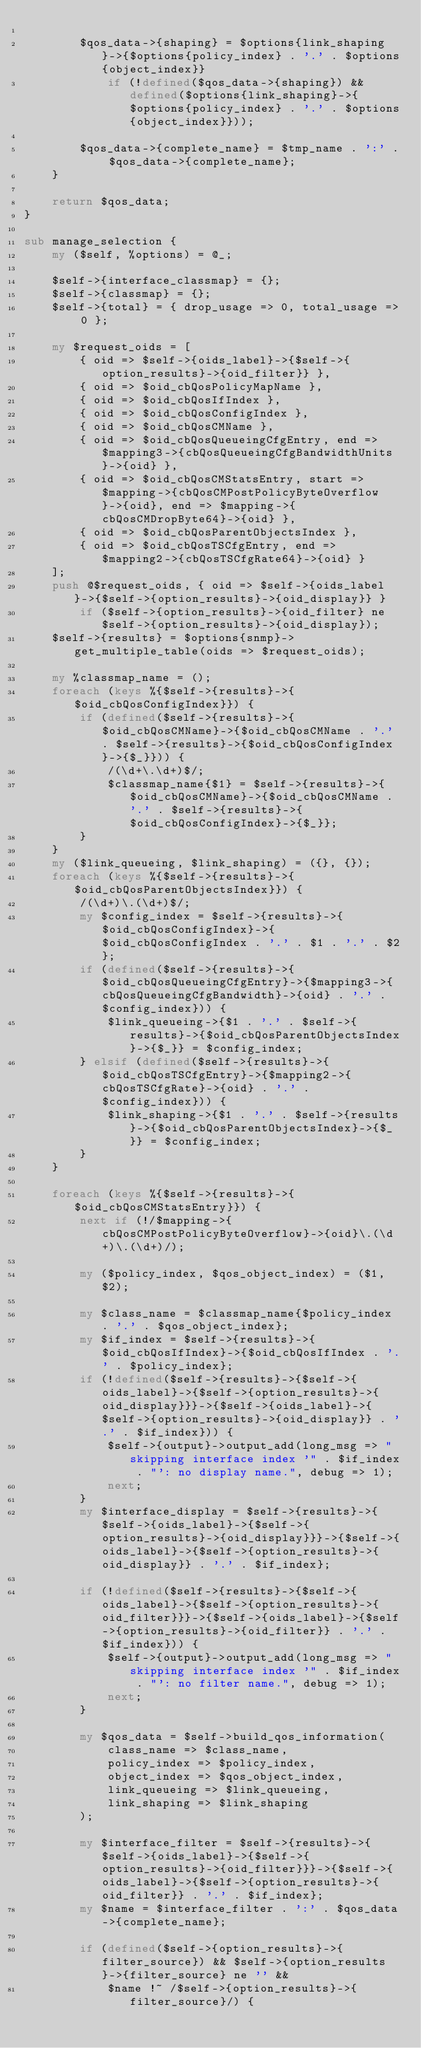<code> <loc_0><loc_0><loc_500><loc_500><_Perl_>
        $qos_data->{shaping} = $options{link_shaping}->{$options{policy_index} . '.' . $options{object_index}}
            if (!defined($qos_data->{shaping}) && defined($options{link_shaping}->{$options{policy_index} . '.' . $options{object_index}}));

        $qos_data->{complete_name} = $tmp_name . ':' . $qos_data->{complete_name};
    }

    return $qos_data;
}

sub manage_selection {
    my ($self, %options) = @_;

    $self->{interface_classmap} = {};
    $self->{classmap} = {};
    $self->{total} = { drop_usage => 0, total_usage => 0 };

    my $request_oids = [
        { oid => $self->{oids_label}->{$self->{option_results}->{oid_filter}} },
        { oid => $oid_cbQosPolicyMapName },
        { oid => $oid_cbQosIfIndex },
        { oid => $oid_cbQosConfigIndex },
        { oid => $oid_cbQosCMName },
        { oid => $oid_cbQosQueueingCfgEntry, end => $mapping3->{cbQosQueueingCfgBandwidthUnits}->{oid} },
        { oid => $oid_cbQosCMStatsEntry, start => $mapping->{cbQosCMPostPolicyByteOverflow}->{oid}, end => $mapping->{cbQosCMDropByte64}->{oid} },
        { oid => $oid_cbQosParentObjectsIndex },
        { oid => $oid_cbQosTSCfgEntry, end => $mapping2->{cbQosTSCfgRate64}->{oid} }
    ];
    push @$request_oids, { oid => $self->{oids_label}->{$self->{option_results}->{oid_display}} } 
        if ($self->{option_results}->{oid_filter} ne $self->{option_results}->{oid_display});
    $self->{results} = $options{snmp}->get_multiple_table(oids => $request_oids);

    my %classmap_name = ();
    foreach (keys %{$self->{results}->{$oid_cbQosConfigIndex}}) {
        if (defined($self->{results}->{$oid_cbQosCMName}->{$oid_cbQosCMName . '.' . $self->{results}->{$oid_cbQosConfigIndex}->{$_}})) {
            /(\d+\.\d+)$/;
            $classmap_name{$1} = $self->{results}->{$oid_cbQosCMName}->{$oid_cbQosCMName . '.' . $self->{results}->{$oid_cbQosConfigIndex}->{$_}};
        }
    }
    my ($link_queueing, $link_shaping) = ({}, {});
    foreach (keys %{$self->{results}->{$oid_cbQosParentObjectsIndex}}) {
        /(\d+)\.(\d+)$/;
        my $config_index = $self->{results}->{$oid_cbQosConfigIndex}->{$oid_cbQosConfigIndex . '.' . $1 . '.' . $2};
        if (defined($self->{results}->{$oid_cbQosQueueingCfgEntry}->{$mapping3->{cbQosQueueingCfgBandwidth}->{oid} . '.' . $config_index})) {
            $link_queueing->{$1 . '.' . $self->{results}->{$oid_cbQosParentObjectsIndex}->{$_}} = $config_index;
        } elsif (defined($self->{results}->{$oid_cbQosTSCfgEntry}->{$mapping2->{cbQosTSCfgRate}->{oid} . '.' . $config_index})) {
            $link_shaping->{$1 . '.' . $self->{results}->{$oid_cbQosParentObjectsIndex}->{$_}} = $config_index;
        }
    }

    foreach (keys %{$self->{results}->{$oid_cbQosCMStatsEntry}}) {
        next if (!/$mapping->{cbQosCMPostPolicyByteOverflow}->{oid}\.(\d+)\.(\d+)/);

        my ($policy_index, $qos_object_index) = ($1, $2);

        my $class_name = $classmap_name{$policy_index . '.' . $qos_object_index};
        my $if_index = $self->{results}->{$oid_cbQosIfIndex}->{$oid_cbQosIfIndex . '.' . $policy_index};
        if (!defined($self->{results}->{$self->{oids_label}->{$self->{option_results}->{oid_display}}}->{$self->{oids_label}->{$self->{option_results}->{oid_display}} . '.' . $if_index})) {
            $self->{output}->output_add(long_msg => "skipping interface index '" . $if_index . "': no display name.", debug => 1);
            next;
        }
        my $interface_display = $self->{results}->{$self->{oids_label}->{$self->{option_results}->{oid_display}}}->{$self->{oids_label}->{$self->{option_results}->{oid_display}} . '.' . $if_index};
        
        if (!defined($self->{results}->{$self->{oids_label}->{$self->{option_results}->{oid_filter}}}->{$self->{oids_label}->{$self->{option_results}->{oid_filter}} . '.' . $if_index})) {
            $self->{output}->output_add(long_msg => "skipping interface index '" . $if_index . "': no filter name.", debug => 1);
            next;
        }

        my $qos_data = $self->build_qos_information(
            class_name => $class_name,
            policy_index => $policy_index,
            object_index => $qos_object_index,
            link_queueing => $link_queueing,
            link_shaping => $link_shaping
        );

        my $interface_filter = $self->{results}->{$self->{oids_label}->{$self->{option_results}->{oid_filter}}}->{$self->{oids_label}->{$self->{option_results}->{oid_filter}} . '.' . $if_index};
        my $name = $interface_filter . ':' . $qos_data->{complete_name};

        if (defined($self->{option_results}->{filter_source}) && $self->{option_results}->{filter_source} ne '' &&
            $name !~ /$self->{option_results}->{filter_source}/) {</code> 